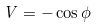Convert formula to latex. <formula><loc_0><loc_0><loc_500><loc_500>V = - \cos \phi</formula> 